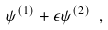<formula> <loc_0><loc_0><loc_500><loc_500>\psi ^ { ( 1 ) } + \epsilon \psi ^ { ( 2 ) } \ ,</formula> 